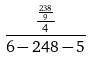Convert formula to latex. <formula><loc_0><loc_0><loc_500><loc_500>\frac { \frac { \frac { 2 3 8 } { 9 } } { 4 } } { 6 - 2 4 8 - 5 }</formula> 